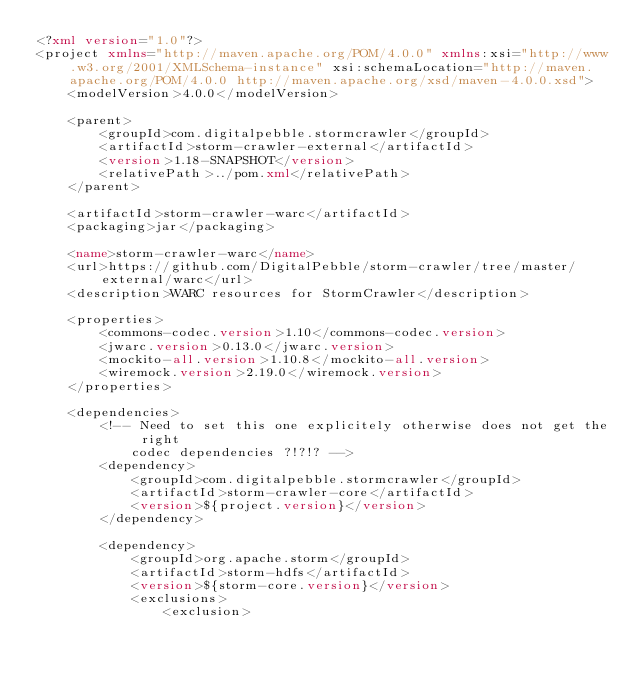<code> <loc_0><loc_0><loc_500><loc_500><_XML_><?xml version="1.0"?>
<project xmlns="http://maven.apache.org/POM/4.0.0" xmlns:xsi="http://www.w3.org/2001/XMLSchema-instance" xsi:schemaLocation="http://maven.apache.org/POM/4.0.0 http://maven.apache.org/xsd/maven-4.0.0.xsd">
	<modelVersion>4.0.0</modelVersion>

	<parent>
		<groupId>com.digitalpebble.stormcrawler</groupId>
		<artifactId>storm-crawler-external</artifactId>
		<version>1.18-SNAPSHOT</version>
		<relativePath>../pom.xml</relativePath>
	</parent>

	<artifactId>storm-crawler-warc</artifactId>
	<packaging>jar</packaging>

	<name>storm-crawler-warc</name>
	<url>https://github.com/DigitalPebble/storm-crawler/tree/master/external/warc</url>
	<description>WARC resources for StormCrawler</description>

	<properties>
		<commons-codec.version>1.10</commons-codec.version>
		<jwarc.version>0.13.0</jwarc.version>
		<mockito-all.version>1.10.8</mockito-all.version>
		<wiremock.version>2.19.0</wiremock.version>
	</properties>

	<dependencies>
		<!-- Need to set this one explicitely otherwise does not get the right 
			codec dependencies ?!?!? -->
		<dependency>
			<groupId>com.digitalpebble.stormcrawler</groupId>
			<artifactId>storm-crawler-core</artifactId>
			<version>${project.version}</version>
		</dependency>

		<dependency>
			<groupId>org.apache.storm</groupId>
			<artifactId>storm-hdfs</artifactId>
			<version>${storm-core.version}</version>
			<exclusions>
				<exclusion></code> 